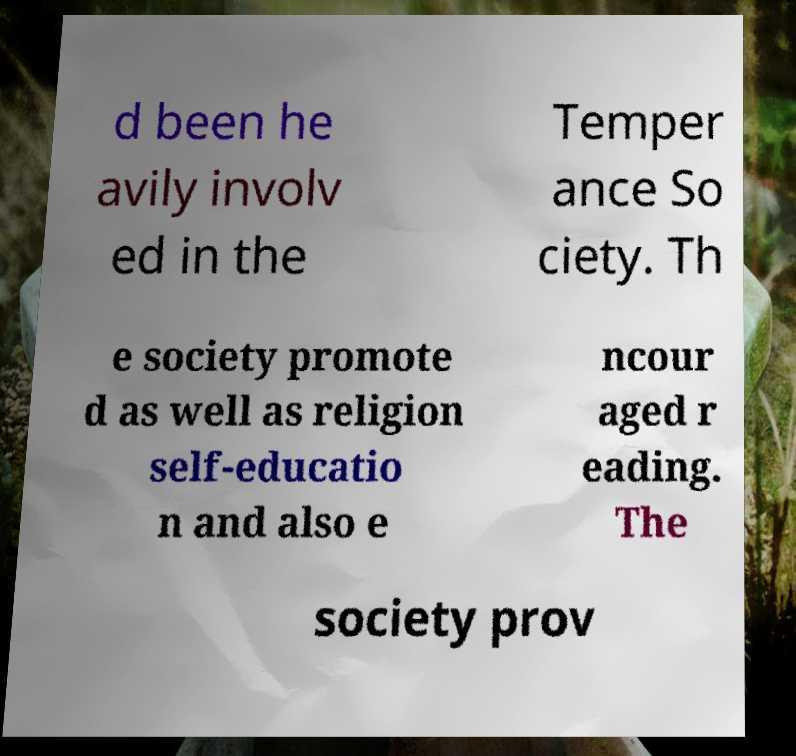Please read and relay the text visible in this image. What does it say? d been he avily involv ed in the Temper ance So ciety. Th e society promote d as well as religion self-educatio n and also e ncour aged r eading. The society prov 